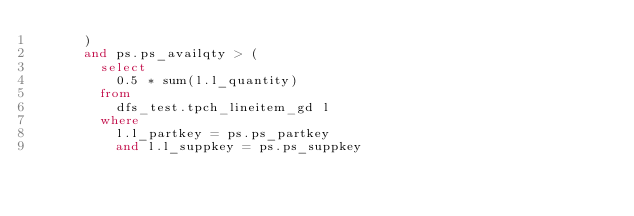Convert code to text. <code><loc_0><loc_0><loc_500><loc_500><_SQL_>      )
      and ps.ps_availqty > (
        select
          0.5 * sum(l.l_quantity)
        from
          dfs_test.tpch_lineitem_gd l
        where
          l.l_partkey = ps.ps_partkey
          and l.l_suppkey = ps.ps_suppkey</code> 